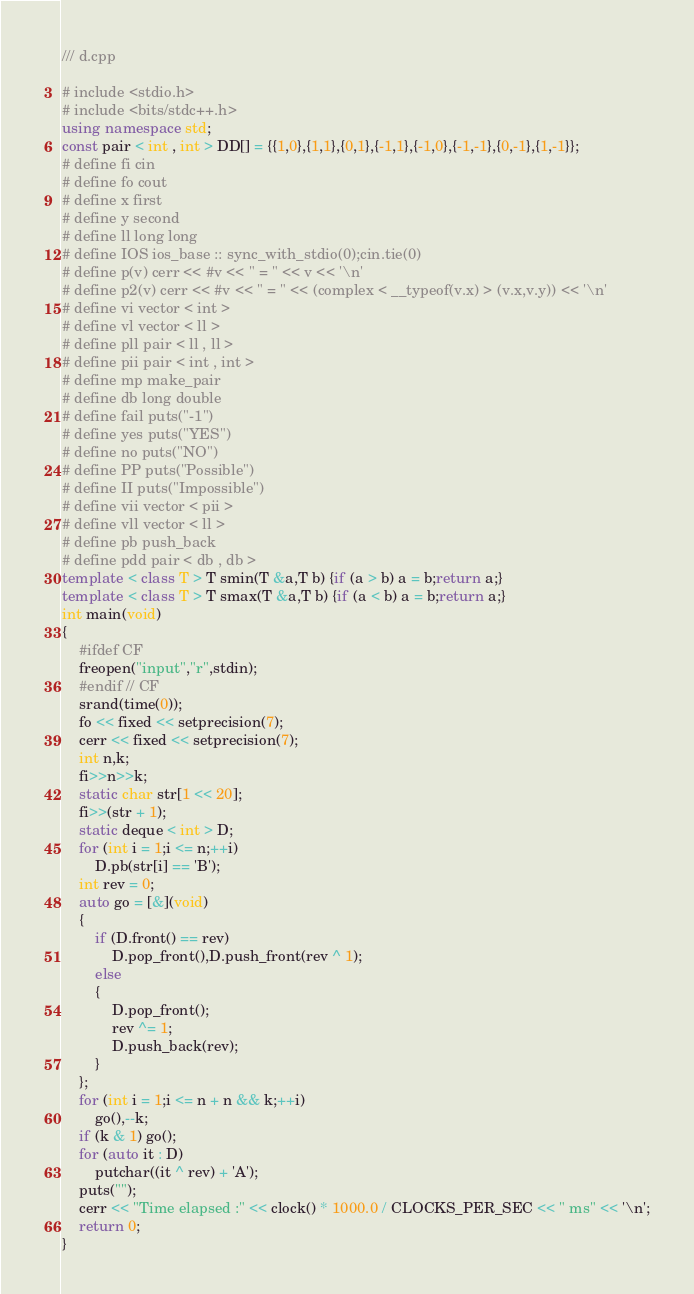Convert code to text. <code><loc_0><loc_0><loc_500><loc_500><_C++_>/// d.cpp

# include <stdio.h>
# include <bits/stdc++.h>
using namespace std;
const pair < int , int > DD[] = {{1,0},{1,1},{0,1},{-1,1},{-1,0},{-1,-1},{0,-1},{1,-1}};
# define fi cin
# define fo cout
# define x first
# define y second
# define ll long long
# define IOS ios_base :: sync_with_stdio(0);cin.tie(0)
# define p(v) cerr << #v << " = " << v << '\n'
# define p2(v) cerr << #v << " = " << (complex < __typeof(v.x) > (v.x,v.y)) << '\n'
# define vi vector < int >
# define vl vector < ll >
# define pll pair < ll , ll >
# define pii pair < int , int >
# define mp make_pair
# define db long double
# define fail puts("-1")
# define yes puts("YES")
# define no puts("NO")
# define PP puts("Possible")
# define II puts("Impossible")
# define vii vector < pii >
# define vll vector < ll >
# define pb push_back
# define pdd pair < db , db >
template < class T > T smin(T &a,T b) {if (a > b) a = b;return a;}
template < class T > T smax(T &a,T b) {if (a < b) a = b;return a;}
int main(void)
{
    #ifdef CF
    freopen("input","r",stdin);
    #endif // CF
    srand(time(0));
    fo << fixed << setprecision(7);
    cerr << fixed << setprecision(7);
    int n,k;
    fi>>n>>k;
    static char str[1 << 20];
    fi>>(str + 1);
    static deque < int > D;
    for (int i = 1;i <= n;++i)
        D.pb(str[i] == 'B');
    int rev = 0;
    auto go = [&](void)
    {
        if (D.front() == rev)
            D.pop_front(),D.push_front(rev ^ 1);
        else
        {
            D.pop_front();
            rev ^= 1;
            D.push_back(rev);
        }
    };
    for (int i = 1;i <= n + n && k;++i)
        go(),--k;
    if (k & 1) go();
    for (auto it : D)
        putchar((it ^ rev) + 'A');
    puts("");
    cerr << "Time elapsed :" << clock() * 1000.0 / CLOCKS_PER_SEC << " ms" << '\n';
    return 0;
}
</code> 